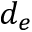<formula> <loc_0><loc_0><loc_500><loc_500>d _ { e }</formula> 